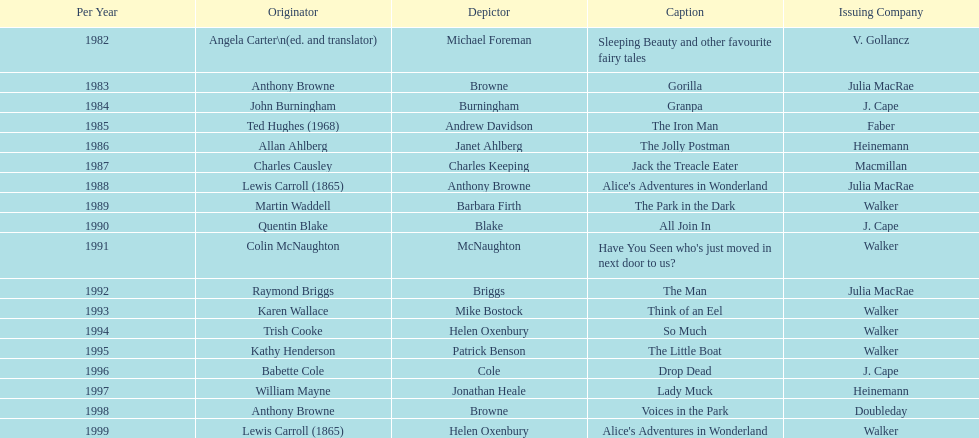What's the difference in years between angela carter's title and anthony browne's? 1. 